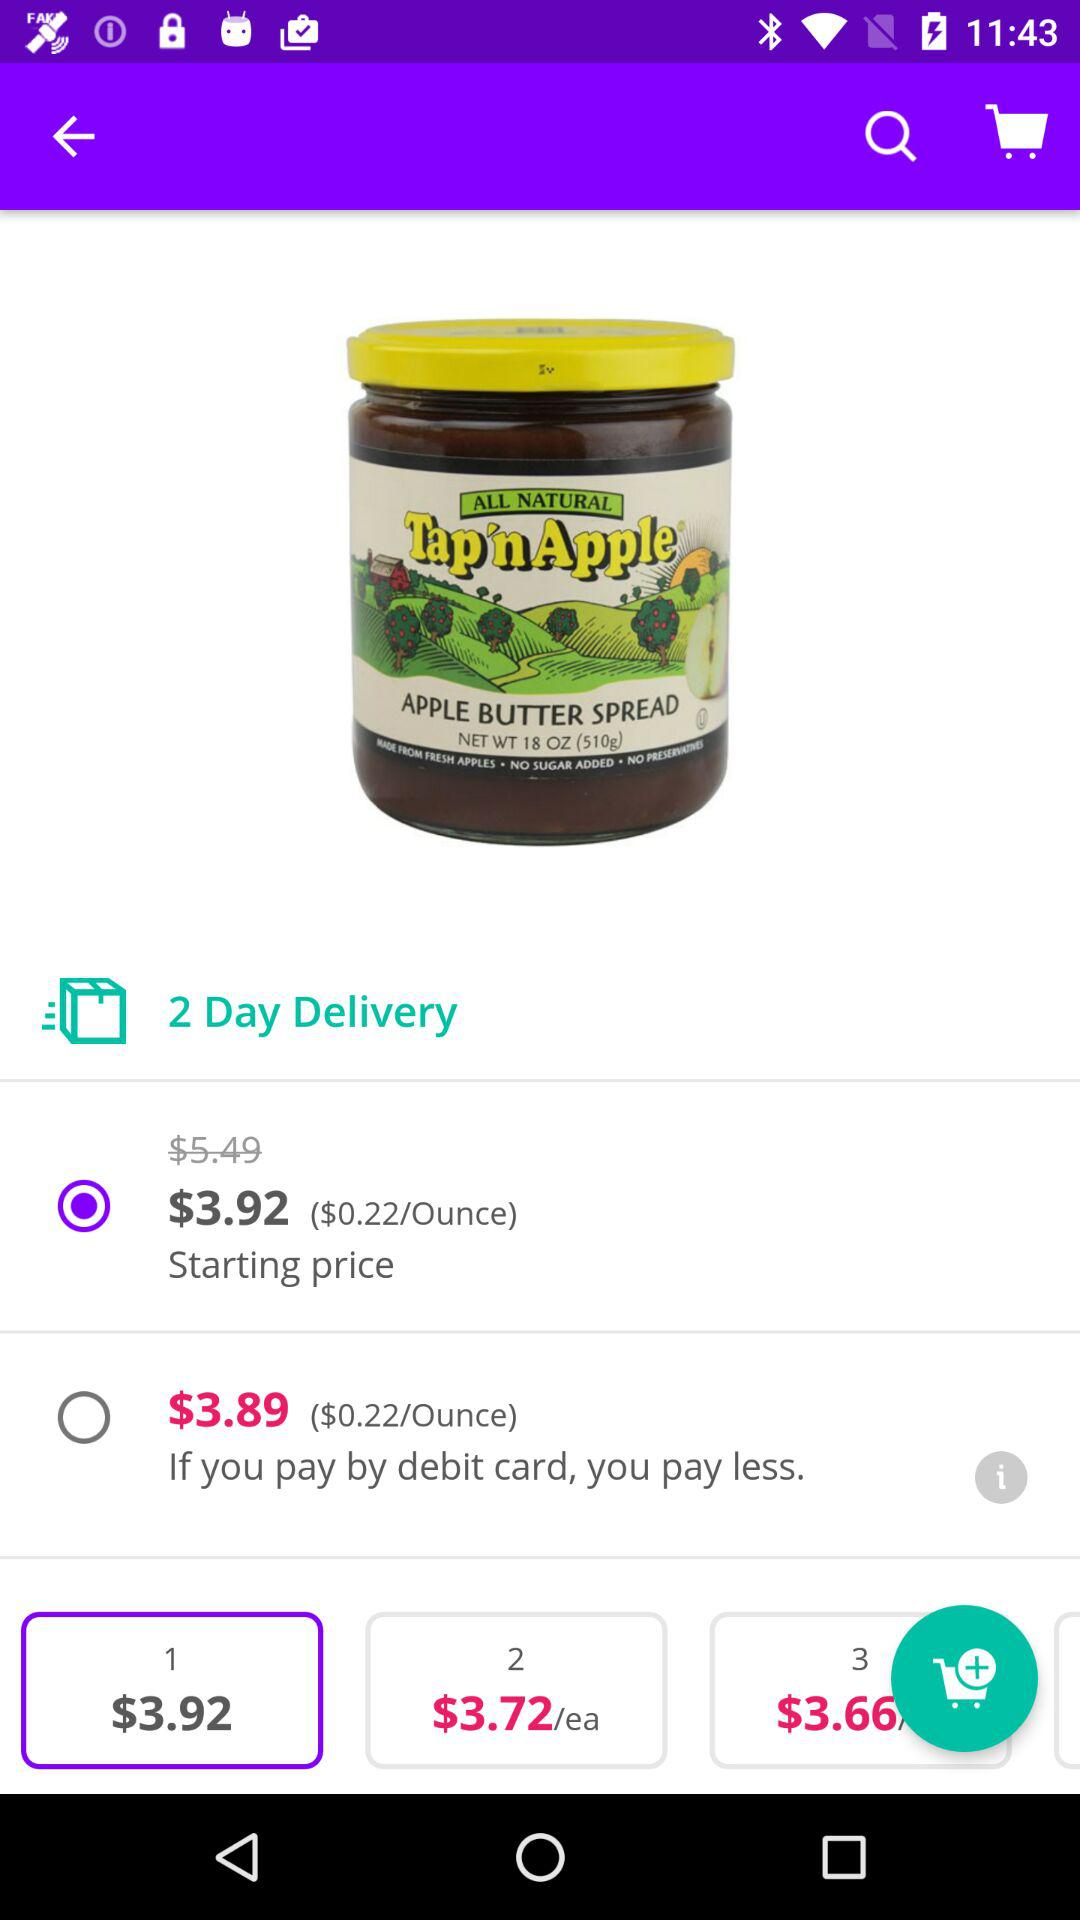What is the price of "APPLE BUTTER SPREAD", if we pay with a debit card? The price is $3.89. 